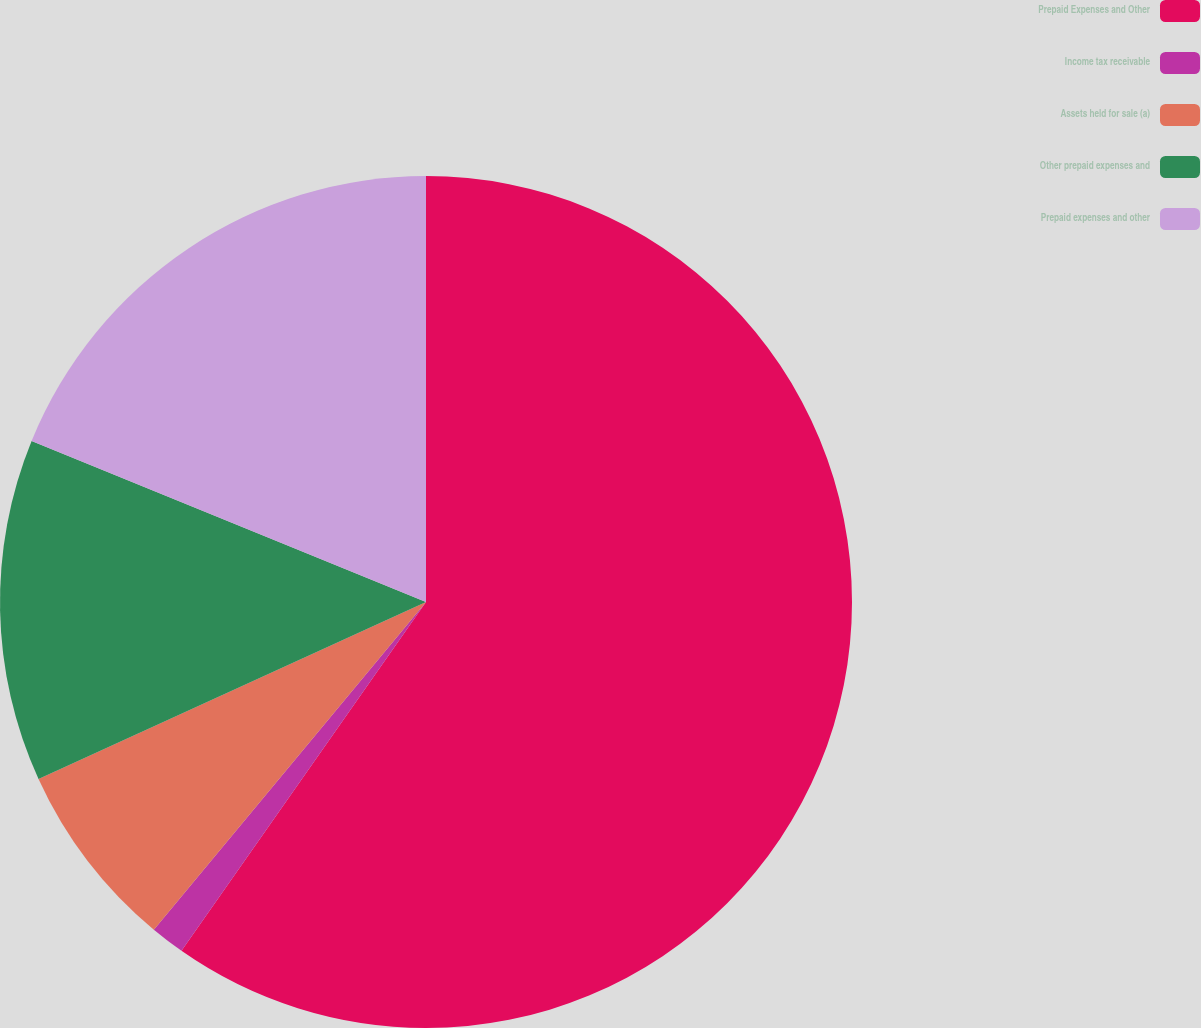Convert chart. <chart><loc_0><loc_0><loc_500><loc_500><pie_chart><fcel>Prepaid Expenses and Other<fcel>Income tax receivable<fcel>Assets held for sale (a)<fcel>Other prepaid expenses and<fcel>Prepaid expenses and other<nl><fcel>59.73%<fcel>1.3%<fcel>7.15%<fcel>12.99%<fcel>18.83%<nl></chart> 